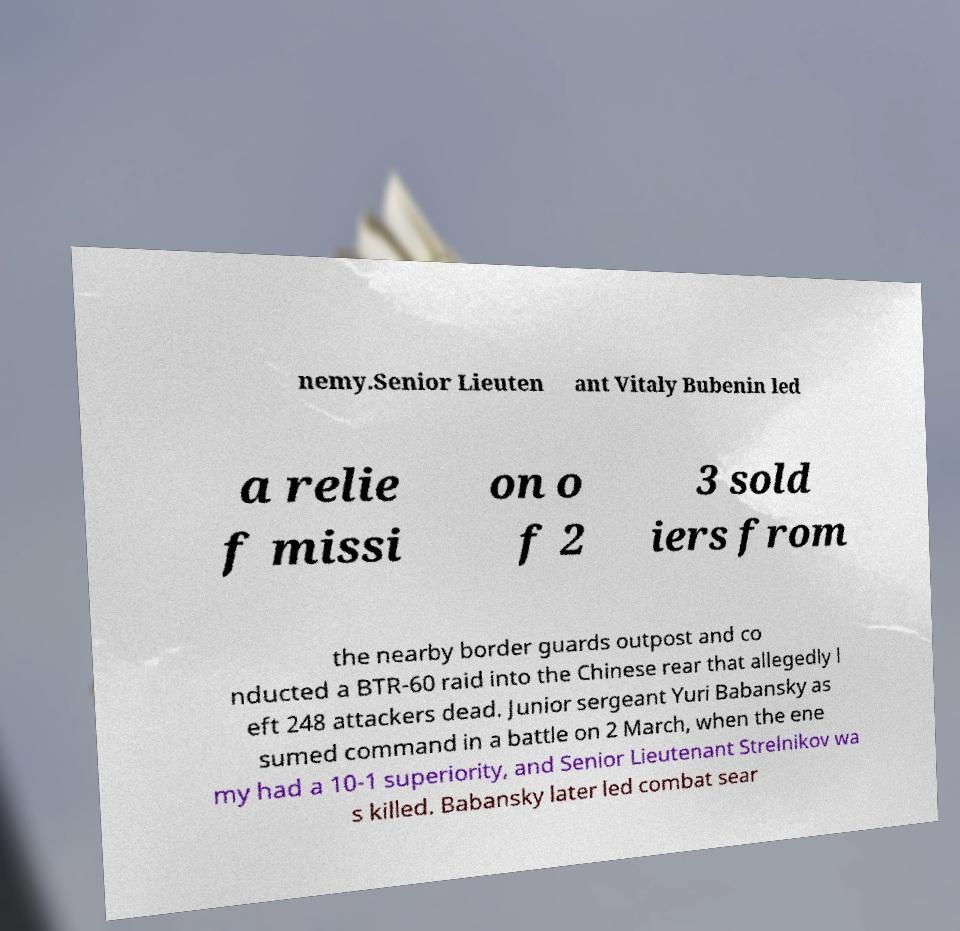What messages or text are displayed in this image? I need them in a readable, typed format. nemy.Senior Lieuten ant Vitaly Bubenin led a relie f missi on o f 2 3 sold iers from the nearby border guards outpost and co nducted a BTR-60 raid into the Chinese rear that allegedly l eft 248 attackers dead. Junior sergeant Yuri Babansky as sumed command in a battle on 2 March, when the ene my had a 10-1 superiority, and Senior Lieutenant Strelnikov wa s killed. Babansky later led combat sear 